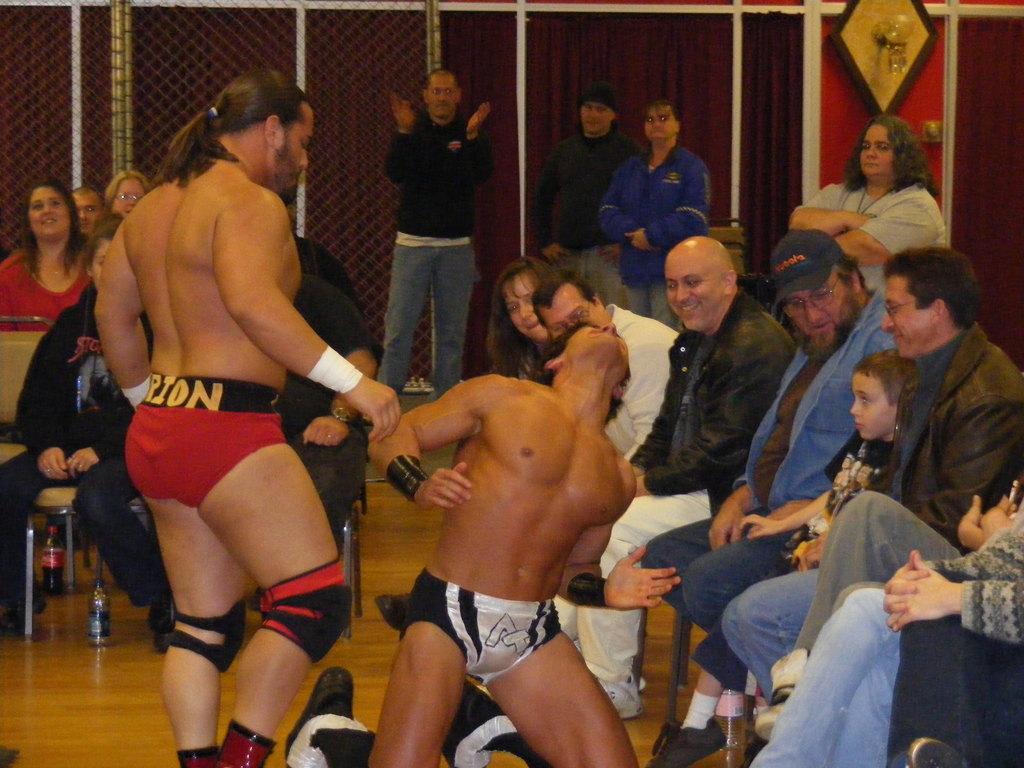Please provide a concise description of this image. In the image there are two wrestlers and around them there are many people, in the background there is a mesh and beside the mesh there is a curtain. 